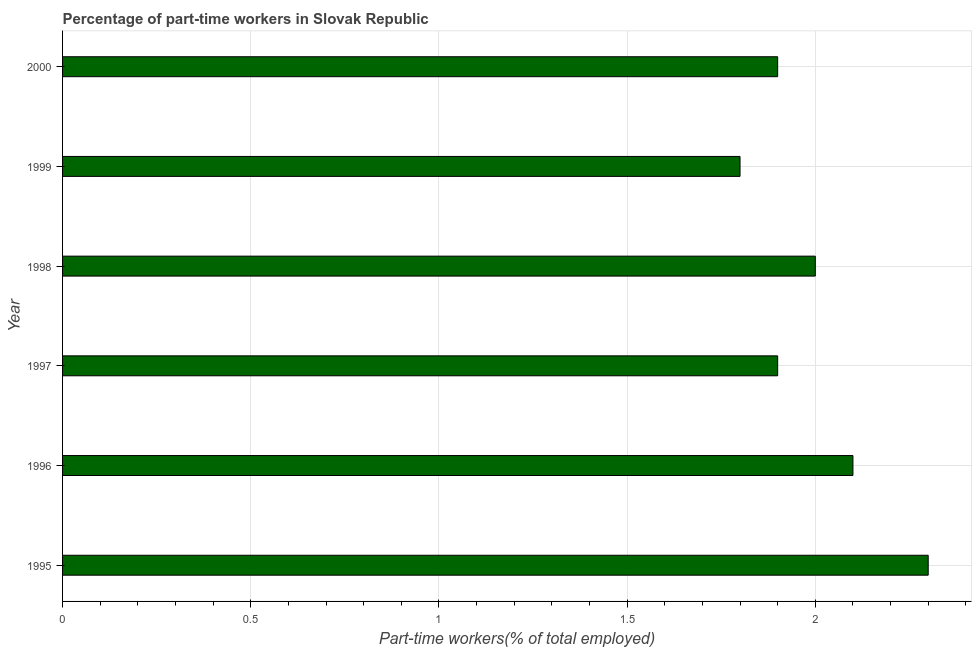What is the title of the graph?
Ensure brevity in your answer.  Percentage of part-time workers in Slovak Republic. What is the label or title of the X-axis?
Give a very brief answer. Part-time workers(% of total employed). What is the label or title of the Y-axis?
Give a very brief answer. Year. What is the percentage of part-time workers in 2000?
Your response must be concise. 1.9. Across all years, what is the maximum percentage of part-time workers?
Give a very brief answer. 2.3. Across all years, what is the minimum percentage of part-time workers?
Offer a very short reply. 1.8. In which year was the percentage of part-time workers maximum?
Make the answer very short. 1995. What is the sum of the percentage of part-time workers?
Give a very brief answer. 12. What is the median percentage of part-time workers?
Your response must be concise. 1.95. In how many years, is the percentage of part-time workers greater than 0.2 %?
Provide a short and direct response. 6. Do a majority of the years between 1999 and 1995 (inclusive) have percentage of part-time workers greater than 2 %?
Make the answer very short. Yes. What is the ratio of the percentage of part-time workers in 1996 to that in 2000?
Give a very brief answer. 1.1. Is the percentage of part-time workers in 1995 less than that in 1999?
Give a very brief answer. No. Is the difference between the percentage of part-time workers in 1995 and 1997 greater than the difference between any two years?
Provide a succinct answer. No. Is the sum of the percentage of part-time workers in 1996 and 1998 greater than the maximum percentage of part-time workers across all years?
Keep it short and to the point. Yes. Are all the bars in the graph horizontal?
Keep it short and to the point. Yes. How many years are there in the graph?
Make the answer very short. 6. What is the Part-time workers(% of total employed) of 1995?
Your answer should be very brief. 2.3. What is the Part-time workers(% of total employed) of 1996?
Keep it short and to the point. 2.1. What is the Part-time workers(% of total employed) in 1997?
Ensure brevity in your answer.  1.9. What is the Part-time workers(% of total employed) in 1999?
Offer a terse response. 1.8. What is the Part-time workers(% of total employed) in 2000?
Make the answer very short. 1.9. What is the difference between the Part-time workers(% of total employed) in 1995 and 1996?
Your answer should be compact. 0.2. What is the difference between the Part-time workers(% of total employed) in 1995 and 1997?
Your response must be concise. 0.4. What is the difference between the Part-time workers(% of total employed) in 1996 and 1997?
Make the answer very short. 0.2. What is the difference between the Part-time workers(% of total employed) in 1996 and 2000?
Provide a short and direct response. 0.2. What is the difference between the Part-time workers(% of total employed) in 1997 and 1999?
Your answer should be very brief. 0.1. What is the difference between the Part-time workers(% of total employed) in 1997 and 2000?
Give a very brief answer. 0. What is the difference between the Part-time workers(% of total employed) in 1998 and 1999?
Offer a very short reply. 0.2. What is the ratio of the Part-time workers(% of total employed) in 1995 to that in 1996?
Keep it short and to the point. 1.09. What is the ratio of the Part-time workers(% of total employed) in 1995 to that in 1997?
Ensure brevity in your answer.  1.21. What is the ratio of the Part-time workers(% of total employed) in 1995 to that in 1998?
Keep it short and to the point. 1.15. What is the ratio of the Part-time workers(% of total employed) in 1995 to that in 1999?
Offer a terse response. 1.28. What is the ratio of the Part-time workers(% of total employed) in 1995 to that in 2000?
Keep it short and to the point. 1.21. What is the ratio of the Part-time workers(% of total employed) in 1996 to that in 1997?
Your answer should be very brief. 1.1. What is the ratio of the Part-time workers(% of total employed) in 1996 to that in 1998?
Keep it short and to the point. 1.05. What is the ratio of the Part-time workers(% of total employed) in 1996 to that in 1999?
Provide a short and direct response. 1.17. What is the ratio of the Part-time workers(% of total employed) in 1996 to that in 2000?
Ensure brevity in your answer.  1.1. What is the ratio of the Part-time workers(% of total employed) in 1997 to that in 1999?
Give a very brief answer. 1.06. What is the ratio of the Part-time workers(% of total employed) in 1998 to that in 1999?
Offer a very short reply. 1.11. What is the ratio of the Part-time workers(% of total employed) in 1998 to that in 2000?
Keep it short and to the point. 1.05. What is the ratio of the Part-time workers(% of total employed) in 1999 to that in 2000?
Make the answer very short. 0.95. 